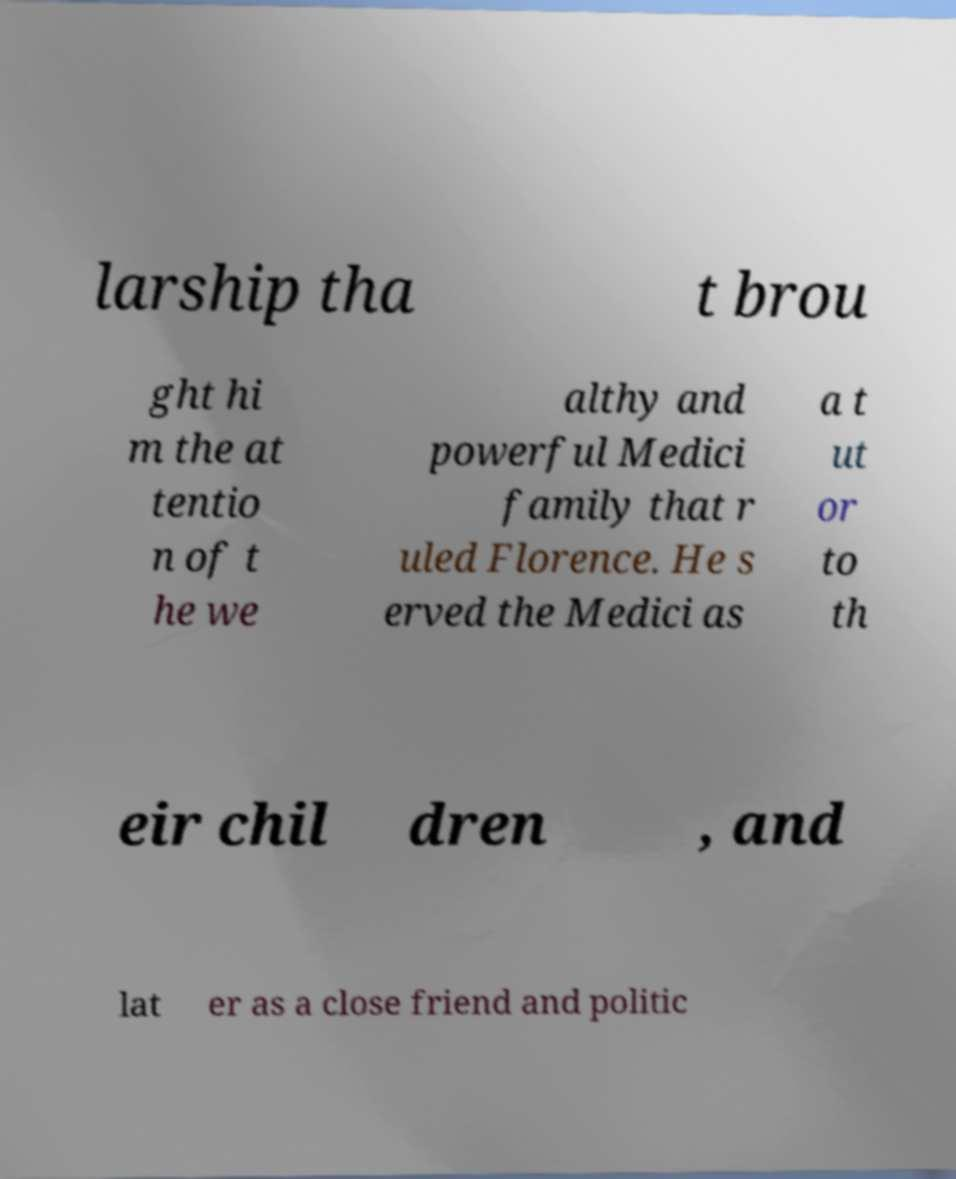Please read and relay the text visible in this image. What does it say? larship tha t brou ght hi m the at tentio n of t he we althy and powerful Medici family that r uled Florence. He s erved the Medici as a t ut or to th eir chil dren , and lat er as a close friend and politic 